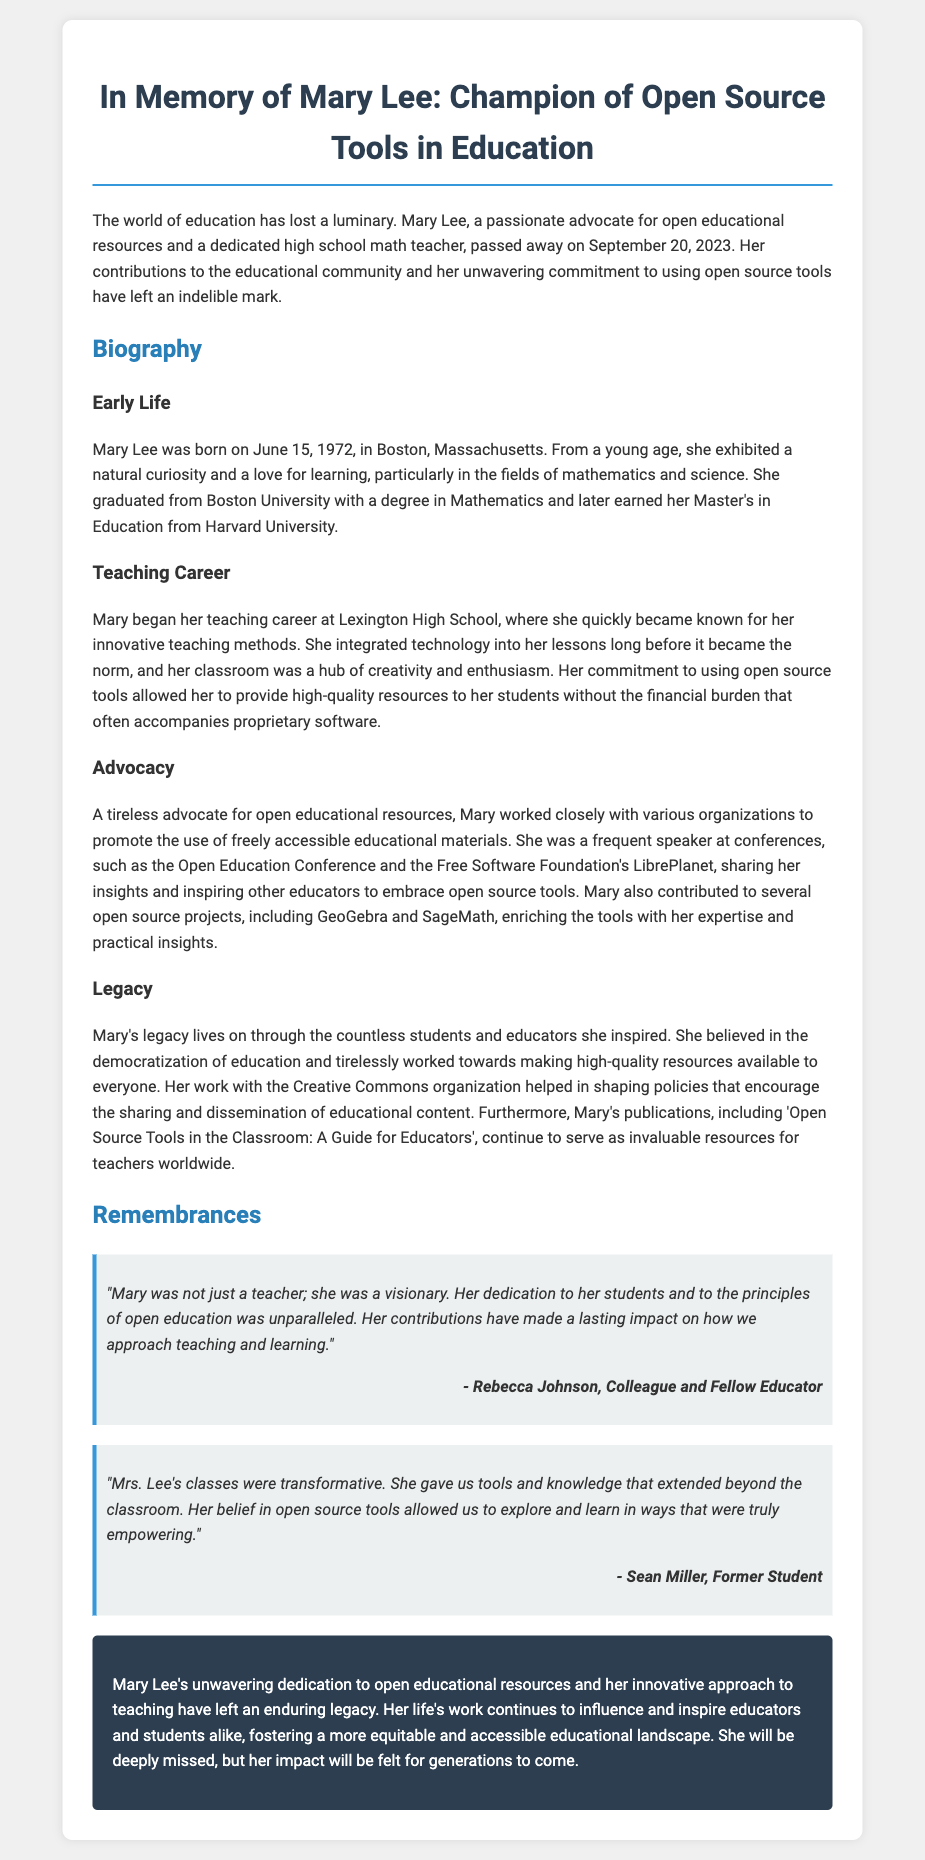What is the full name of the individual honored in the obituary? The full name mentioned in the obituary is Mary Lee.
Answer: Mary Lee When was Mary Lee born? The document states that Mary Lee was born on June 15, 1972.
Answer: June 15, 1972 What degree did Mary Lee earn from Boston University? The document mentions that she graduated with a degree in Mathematics from Boston University.
Answer: Mathematics In which high school did Mary begin her teaching career? According to the document, Mary started her teaching career at Lexington High School.
Answer: Lexington High School What was one of Mary Lee's notable publications? The document highlights 'Open Source Tools in the Classroom: A Guide for Educators' as one of her publications.
Answer: Open Source Tools in the Classroom: A Guide for Educators How many years did Mary Lee live before passing away? Mary Lee passed away on September 20, 2023, and was born on June 15, 1972, which means she lived for 51 years.
Answer: 51 years What was the main focus of Mary Lee’s advocacy work? The document describes her advocacy work as promoting open educational resources.
Answer: Open educational resources Who is quoted reminiscing about Mary Lee in the document? The document includes a quote from Rebecca Johnson, a colleague and fellow educator, reminiscing about Mary.
Answer: Rebecca Johnson What organization did Mary work with to help shape policies for education? According to the obituary, Mary worked with Creative Commons.
Answer: Creative Commons 